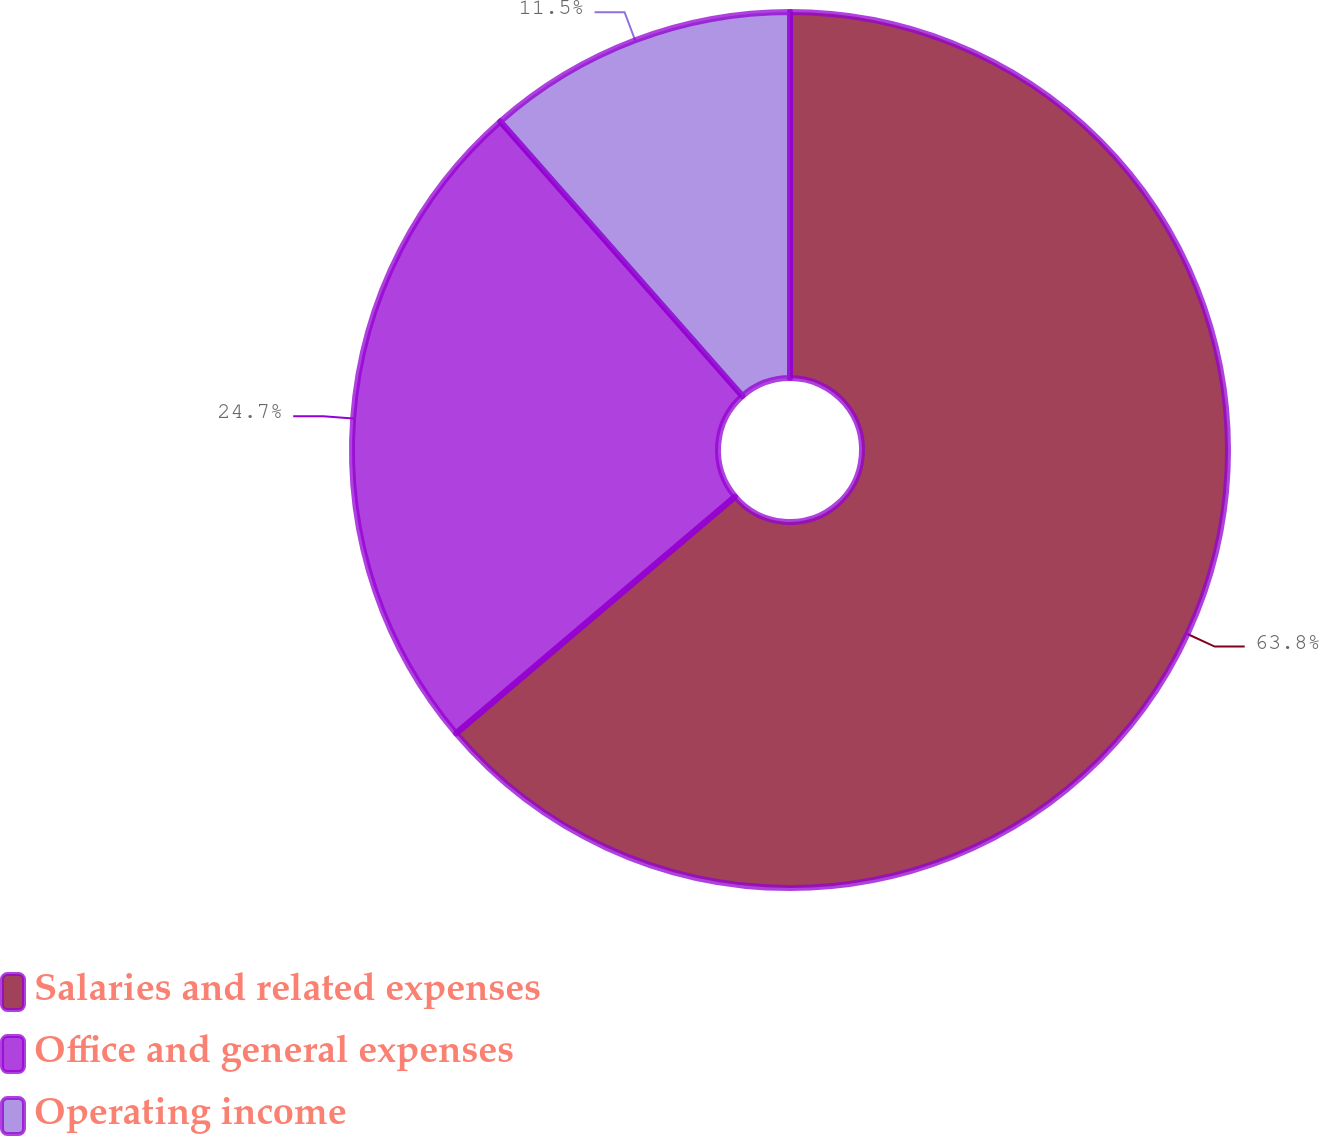<chart> <loc_0><loc_0><loc_500><loc_500><pie_chart><fcel>Salaries and related expenses<fcel>Office and general expenses<fcel>Operating income<nl><fcel>63.8%<fcel>24.7%<fcel>11.5%<nl></chart> 